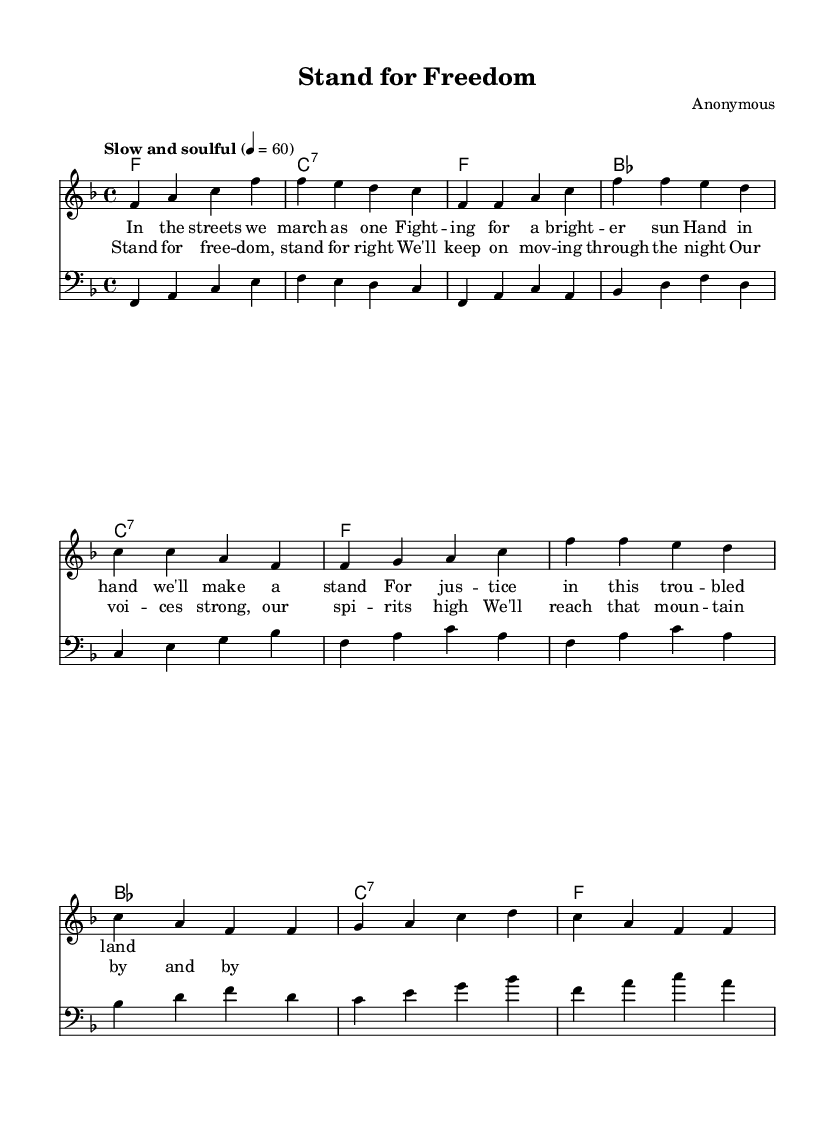What is the key signature of this music? The key signature is F major, which has one flat (B flat). This can be identified at the beginning of the staff where the key signature is indicated.
Answer: F major What is the time signature of this music? The time signature is 4/4, which can be found at the beginning of the music, indicating four beats in each measure.
Answer: 4/4 What is the tempo marking for this piece? The tempo marking is "Slow and soulful." This is provided at the beginning of the score, indicating the desired speed and feel of the music.
Answer: Slow and soulful How many measures are in the chorus section? The chorus section consists of 4 measures, as can be counted from the notes and chords indicated specifically in the chorus section.
Answer: 4 What type of music is this piece categorized as? This piece is categorized as Rhythm and Blues, which is suggested by the soulful melody and lyrical content reflecting societal issues, typical of R&B music of the 1960s.
Answer: Rhythm and Blues How do the melodies in the verse and chorus compare in terms of note range? The melody in the chorus tends to reach higher notes compared to the verse, showcasing a progression in emotional intensity from the verse to the chorus. This can be deduced by analyzing the relative pitches in each section.
Answer: Higher in chorus What do the lyrics in the chorus emphasize in relation to the Civil Rights Movement? The lyrics in the chorus emphasize perseverance and unity, with phrases promoting strength and continued movement towards justice, reflecting the sentiments and struggles of the Civil Rights Movement.
Answer: Perseverance and unity 